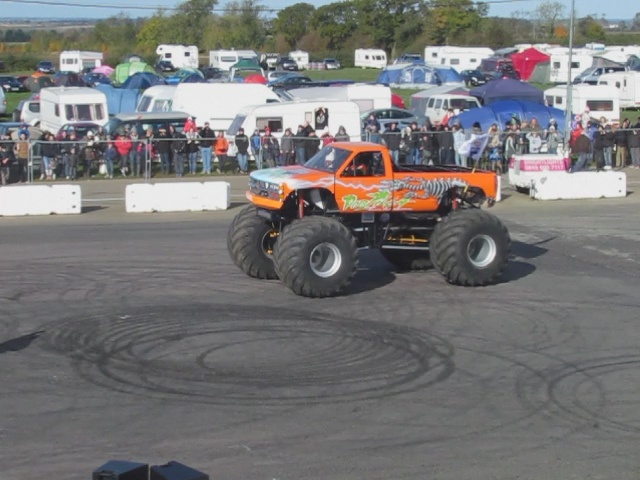Describe the objects in this image and their specific colors. I can see truck in darkgray, gray, black, and red tones, people in darkgray, gray, lightgray, and black tones, truck in darkgray, lightgray, and gray tones, truck in darkgray, lightgray, and gray tones, and car in darkgray, gray, and lightgray tones in this image. 